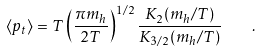Convert formula to latex. <formula><loc_0><loc_0><loc_500><loc_500>\langle p _ { t } \rangle = T \left ( \frac { \pi m _ { h } } { 2 T } \right ) ^ { 1 / 2 } \frac { K _ { 2 } ( m _ { h } / T ) } { K _ { 3 / 2 } ( m _ { h } / T ) } \quad .</formula> 